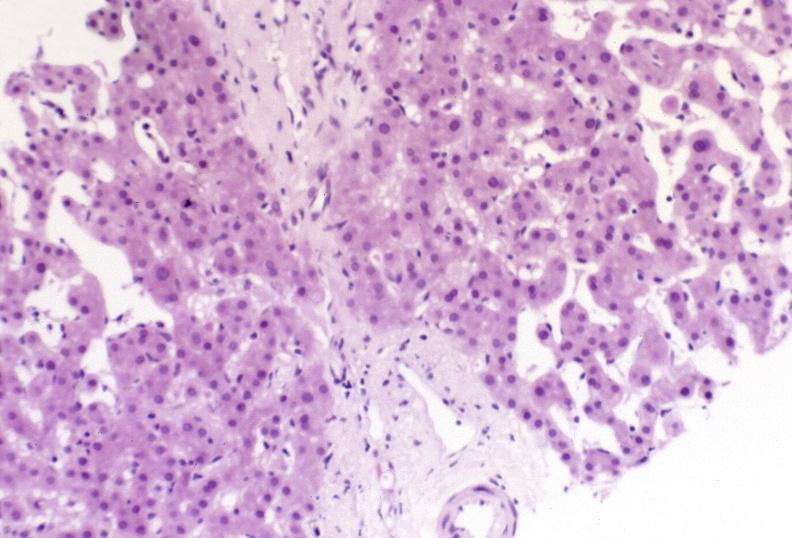s liver present?
Answer the question using a single word or phrase. Yes 